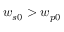<formula> <loc_0><loc_0><loc_500><loc_500>w _ { s 0 } > w _ { p 0 }</formula> 